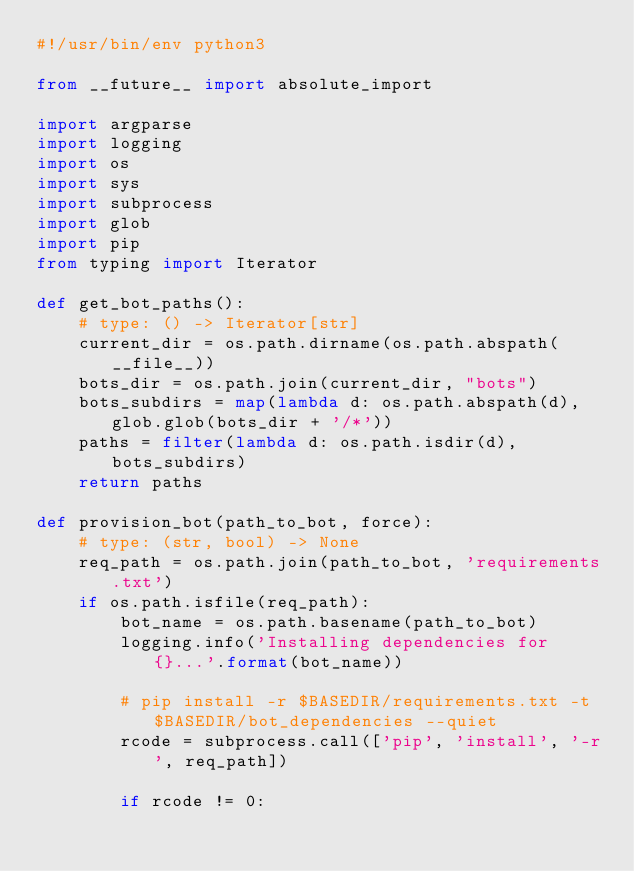<code> <loc_0><loc_0><loc_500><loc_500><_Python_>#!/usr/bin/env python3

from __future__ import absolute_import

import argparse
import logging
import os
import sys
import subprocess
import glob
import pip
from typing import Iterator

def get_bot_paths():
    # type: () -> Iterator[str]
    current_dir = os.path.dirname(os.path.abspath(__file__))
    bots_dir = os.path.join(current_dir, "bots")
    bots_subdirs = map(lambda d: os.path.abspath(d), glob.glob(bots_dir + '/*'))
    paths = filter(lambda d: os.path.isdir(d), bots_subdirs)
    return paths

def provision_bot(path_to_bot, force):
    # type: (str, bool) -> None
    req_path = os.path.join(path_to_bot, 'requirements.txt')
    if os.path.isfile(req_path):
        bot_name = os.path.basename(path_to_bot)
        logging.info('Installing dependencies for {}...'.format(bot_name))

        # pip install -r $BASEDIR/requirements.txt -t $BASEDIR/bot_dependencies --quiet
        rcode = subprocess.call(['pip', 'install', '-r', req_path])

        if rcode != 0:</code> 